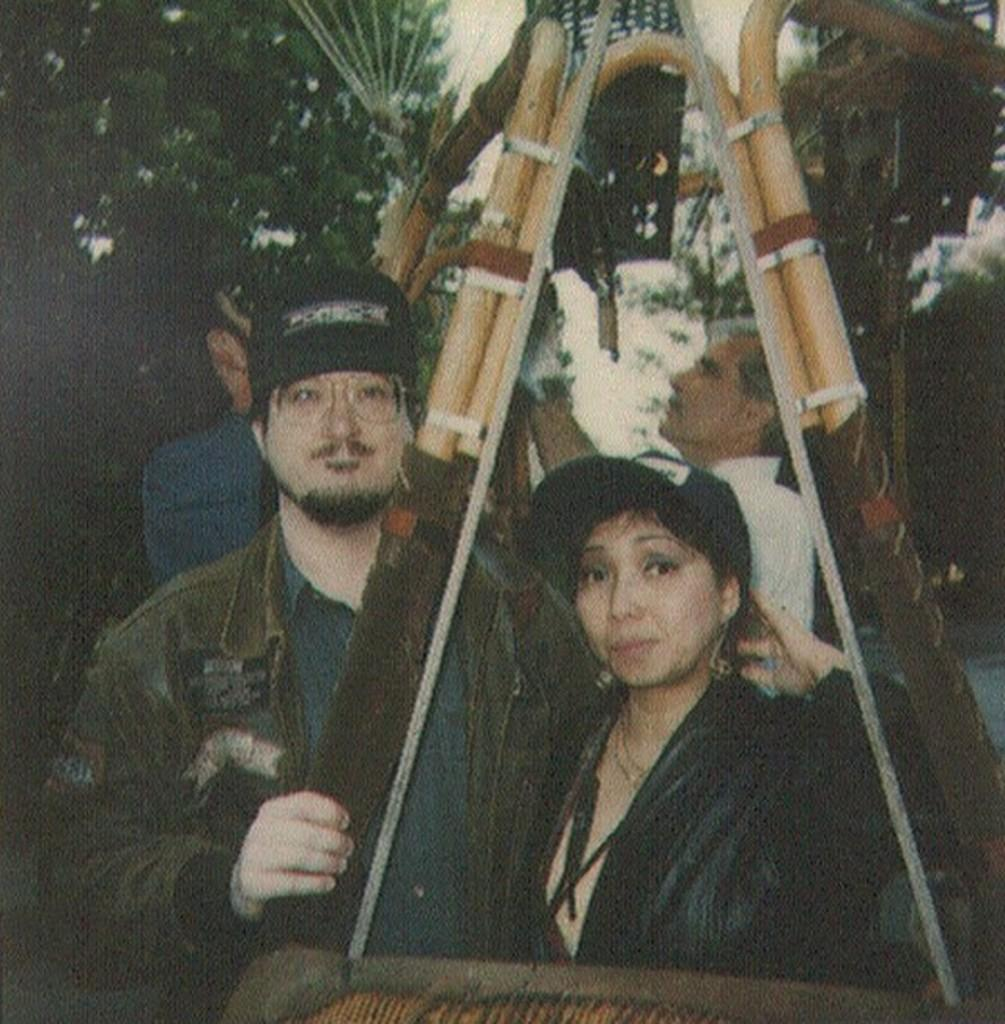How many people are in the image? There are people in the image, but the exact number is not specified. What is the object in front of the people? The facts do not specify what the object is, only that there is an object in front of the people. What can be seen in the background of the image? In the background of the image, there are trees and the sky. Can you describe the environment in the image? The image features people, an object, trees, and the sky, suggesting an outdoor setting. How much water is being consumed by the family in the image? There is no mention of a family or water consumption in the image, so this question cannot be answered definitively. 